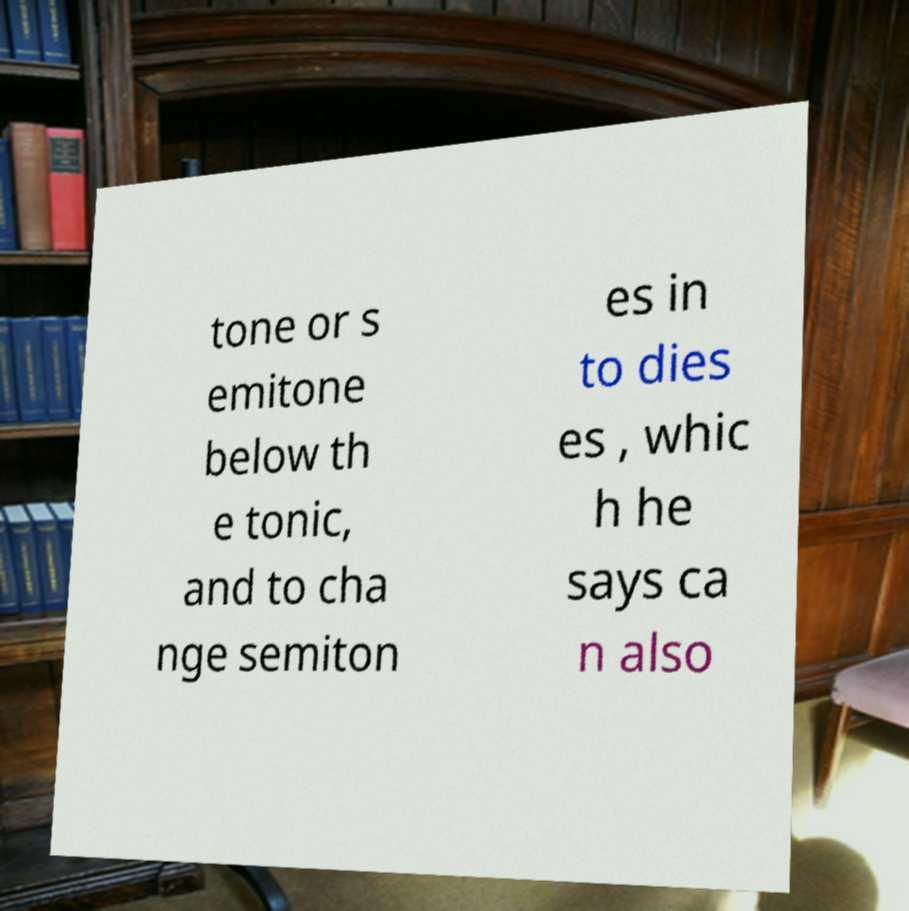Can you accurately transcribe the text from the provided image for me? tone or s emitone below th e tonic, and to cha nge semiton es in to dies es , whic h he says ca n also 